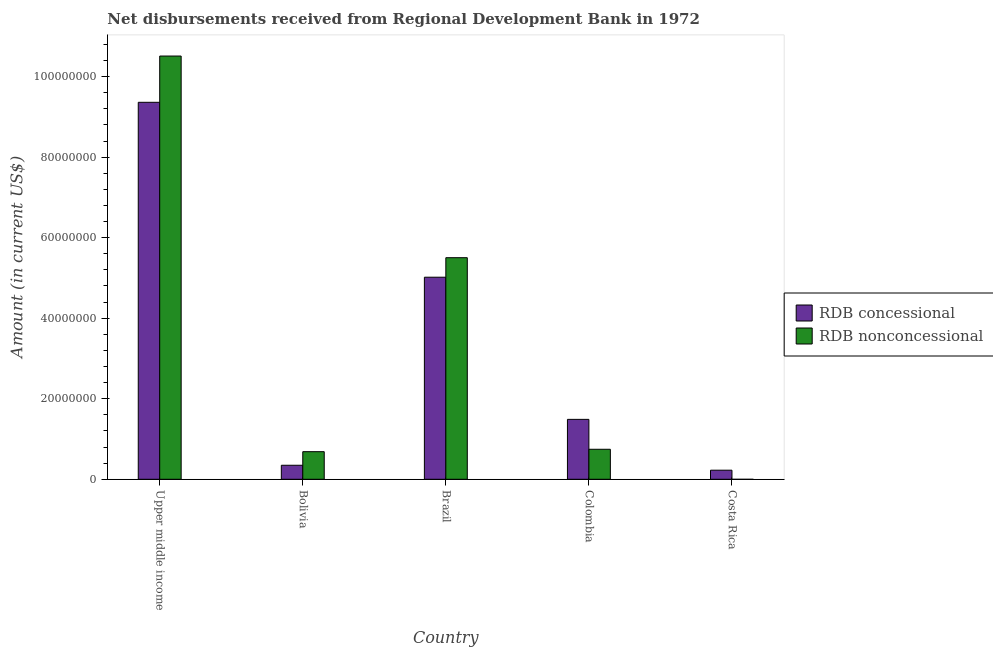Are the number of bars on each tick of the X-axis equal?
Your answer should be very brief. No. What is the net concessional disbursements from rdb in Brazil?
Offer a very short reply. 5.02e+07. Across all countries, what is the maximum net non concessional disbursements from rdb?
Ensure brevity in your answer.  1.05e+08. Across all countries, what is the minimum net concessional disbursements from rdb?
Keep it short and to the point. 2.26e+06. In which country was the net non concessional disbursements from rdb maximum?
Ensure brevity in your answer.  Upper middle income. What is the total net concessional disbursements from rdb in the graph?
Ensure brevity in your answer.  1.64e+08. What is the difference between the net concessional disbursements from rdb in Brazil and that in Upper middle income?
Keep it short and to the point. -4.34e+07. What is the difference between the net concessional disbursements from rdb in Brazil and the net non concessional disbursements from rdb in Colombia?
Your response must be concise. 4.27e+07. What is the average net non concessional disbursements from rdb per country?
Provide a short and direct response. 3.49e+07. What is the difference between the net concessional disbursements from rdb and net non concessional disbursements from rdb in Colombia?
Ensure brevity in your answer.  7.43e+06. In how many countries, is the net concessional disbursements from rdb greater than 64000000 US$?
Offer a very short reply. 1. What is the ratio of the net non concessional disbursements from rdb in Colombia to that in Upper middle income?
Provide a succinct answer. 0.07. Is the difference between the net concessional disbursements from rdb in Colombia and Upper middle income greater than the difference between the net non concessional disbursements from rdb in Colombia and Upper middle income?
Make the answer very short. Yes. What is the difference between the highest and the second highest net non concessional disbursements from rdb?
Provide a short and direct response. 5.01e+07. What is the difference between the highest and the lowest net concessional disbursements from rdb?
Ensure brevity in your answer.  9.14e+07. How many bars are there?
Your answer should be very brief. 9. Are all the bars in the graph horizontal?
Offer a terse response. No. How many countries are there in the graph?
Offer a terse response. 5. Are the values on the major ticks of Y-axis written in scientific E-notation?
Give a very brief answer. No. Does the graph contain any zero values?
Your response must be concise. Yes. How are the legend labels stacked?
Keep it short and to the point. Vertical. What is the title of the graph?
Your answer should be compact. Net disbursements received from Regional Development Bank in 1972. What is the label or title of the X-axis?
Keep it short and to the point. Country. What is the label or title of the Y-axis?
Give a very brief answer. Amount (in current US$). What is the Amount (in current US$) in RDB concessional in Upper middle income?
Give a very brief answer. 9.36e+07. What is the Amount (in current US$) of RDB nonconcessional in Upper middle income?
Offer a terse response. 1.05e+08. What is the Amount (in current US$) of RDB concessional in Bolivia?
Provide a short and direct response. 3.48e+06. What is the Amount (in current US$) in RDB nonconcessional in Bolivia?
Offer a very short reply. 6.85e+06. What is the Amount (in current US$) in RDB concessional in Brazil?
Offer a terse response. 5.02e+07. What is the Amount (in current US$) in RDB nonconcessional in Brazil?
Provide a succinct answer. 5.50e+07. What is the Amount (in current US$) in RDB concessional in Colombia?
Provide a succinct answer. 1.49e+07. What is the Amount (in current US$) in RDB nonconcessional in Colombia?
Offer a very short reply. 7.45e+06. What is the Amount (in current US$) in RDB concessional in Costa Rica?
Provide a short and direct response. 2.26e+06. What is the Amount (in current US$) in RDB nonconcessional in Costa Rica?
Your answer should be compact. 0. Across all countries, what is the maximum Amount (in current US$) in RDB concessional?
Ensure brevity in your answer.  9.36e+07. Across all countries, what is the maximum Amount (in current US$) in RDB nonconcessional?
Provide a succinct answer. 1.05e+08. Across all countries, what is the minimum Amount (in current US$) of RDB concessional?
Offer a very short reply. 2.26e+06. Across all countries, what is the minimum Amount (in current US$) of RDB nonconcessional?
Keep it short and to the point. 0. What is the total Amount (in current US$) of RDB concessional in the graph?
Provide a short and direct response. 1.64e+08. What is the total Amount (in current US$) of RDB nonconcessional in the graph?
Your response must be concise. 1.74e+08. What is the difference between the Amount (in current US$) of RDB concessional in Upper middle income and that in Bolivia?
Provide a short and direct response. 9.01e+07. What is the difference between the Amount (in current US$) in RDB nonconcessional in Upper middle income and that in Bolivia?
Ensure brevity in your answer.  9.82e+07. What is the difference between the Amount (in current US$) in RDB concessional in Upper middle income and that in Brazil?
Your response must be concise. 4.34e+07. What is the difference between the Amount (in current US$) of RDB nonconcessional in Upper middle income and that in Brazil?
Give a very brief answer. 5.01e+07. What is the difference between the Amount (in current US$) in RDB concessional in Upper middle income and that in Colombia?
Offer a terse response. 7.87e+07. What is the difference between the Amount (in current US$) in RDB nonconcessional in Upper middle income and that in Colombia?
Your answer should be compact. 9.76e+07. What is the difference between the Amount (in current US$) of RDB concessional in Upper middle income and that in Costa Rica?
Offer a terse response. 9.14e+07. What is the difference between the Amount (in current US$) of RDB concessional in Bolivia and that in Brazil?
Offer a very short reply. -4.67e+07. What is the difference between the Amount (in current US$) of RDB nonconcessional in Bolivia and that in Brazil?
Provide a short and direct response. -4.82e+07. What is the difference between the Amount (in current US$) of RDB concessional in Bolivia and that in Colombia?
Offer a terse response. -1.14e+07. What is the difference between the Amount (in current US$) of RDB nonconcessional in Bolivia and that in Colombia?
Your answer should be very brief. -5.97e+05. What is the difference between the Amount (in current US$) in RDB concessional in Bolivia and that in Costa Rica?
Make the answer very short. 1.22e+06. What is the difference between the Amount (in current US$) of RDB concessional in Brazil and that in Colombia?
Provide a succinct answer. 3.53e+07. What is the difference between the Amount (in current US$) of RDB nonconcessional in Brazil and that in Colombia?
Your response must be concise. 4.76e+07. What is the difference between the Amount (in current US$) of RDB concessional in Brazil and that in Costa Rica?
Offer a terse response. 4.79e+07. What is the difference between the Amount (in current US$) in RDB concessional in Colombia and that in Costa Rica?
Provide a succinct answer. 1.26e+07. What is the difference between the Amount (in current US$) of RDB concessional in Upper middle income and the Amount (in current US$) of RDB nonconcessional in Bolivia?
Offer a very short reply. 8.68e+07. What is the difference between the Amount (in current US$) of RDB concessional in Upper middle income and the Amount (in current US$) of RDB nonconcessional in Brazil?
Your answer should be compact. 3.86e+07. What is the difference between the Amount (in current US$) of RDB concessional in Upper middle income and the Amount (in current US$) of RDB nonconcessional in Colombia?
Offer a very short reply. 8.62e+07. What is the difference between the Amount (in current US$) in RDB concessional in Bolivia and the Amount (in current US$) in RDB nonconcessional in Brazil?
Give a very brief answer. -5.15e+07. What is the difference between the Amount (in current US$) in RDB concessional in Bolivia and the Amount (in current US$) in RDB nonconcessional in Colombia?
Ensure brevity in your answer.  -3.97e+06. What is the difference between the Amount (in current US$) of RDB concessional in Brazil and the Amount (in current US$) of RDB nonconcessional in Colombia?
Keep it short and to the point. 4.27e+07. What is the average Amount (in current US$) in RDB concessional per country?
Give a very brief answer. 3.29e+07. What is the average Amount (in current US$) of RDB nonconcessional per country?
Provide a short and direct response. 3.49e+07. What is the difference between the Amount (in current US$) in RDB concessional and Amount (in current US$) in RDB nonconcessional in Upper middle income?
Provide a short and direct response. -1.15e+07. What is the difference between the Amount (in current US$) in RDB concessional and Amount (in current US$) in RDB nonconcessional in Bolivia?
Offer a terse response. -3.37e+06. What is the difference between the Amount (in current US$) in RDB concessional and Amount (in current US$) in RDB nonconcessional in Brazil?
Your answer should be compact. -4.84e+06. What is the difference between the Amount (in current US$) of RDB concessional and Amount (in current US$) of RDB nonconcessional in Colombia?
Your response must be concise. 7.43e+06. What is the ratio of the Amount (in current US$) of RDB concessional in Upper middle income to that in Bolivia?
Provide a succinct answer. 26.9. What is the ratio of the Amount (in current US$) in RDB nonconcessional in Upper middle income to that in Bolivia?
Your response must be concise. 15.34. What is the ratio of the Amount (in current US$) in RDB concessional in Upper middle income to that in Brazil?
Your response must be concise. 1.87. What is the ratio of the Amount (in current US$) of RDB nonconcessional in Upper middle income to that in Brazil?
Give a very brief answer. 1.91. What is the ratio of the Amount (in current US$) in RDB concessional in Upper middle income to that in Colombia?
Your response must be concise. 6.29. What is the ratio of the Amount (in current US$) of RDB nonconcessional in Upper middle income to that in Colombia?
Your answer should be very brief. 14.11. What is the ratio of the Amount (in current US$) in RDB concessional in Upper middle income to that in Costa Rica?
Give a very brief answer. 41.49. What is the ratio of the Amount (in current US$) in RDB concessional in Bolivia to that in Brazil?
Offer a very short reply. 0.07. What is the ratio of the Amount (in current US$) of RDB nonconcessional in Bolivia to that in Brazil?
Make the answer very short. 0.12. What is the ratio of the Amount (in current US$) in RDB concessional in Bolivia to that in Colombia?
Your answer should be compact. 0.23. What is the ratio of the Amount (in current US$) in RDB nonconcessional in Bolivia to that in Colombia?
Ensure brevity in your answer.  0.92. What is the ratio of the Amount (in current US$) of RDB concessional in Bolivia to that in Costa Rica?
Your answer should be very brief. 1.54. What is the ratio of the Amount (in current US$) of RDB concessional in Brazil to that in Colombia?
Offer a terse response. 3.37. What is the ratio of the Amount (in current US$) in RDB nonconcessional in Brazil to that in Colombia?
Keep it short and to the point. 7.39. What is the ratio of the Amount (in current US$) of RDB concessional in Brazil to that in Costa Rica?
Give a very brief answer. 22.24. What is the ratio of the Amount (in current US$) in RDB concessional in Colombia to that in Costa Rica?
Your answer should be compact. 6.59. What is the difference between the highest and the second highest Amount (in current US$) of RDB concessional?
Your answer should be very brief. 4.34e+07. What is the difference between the highest and the second highest Amount (in current US$) in RDB nonconcessional?
Offer a terse response. 5.01e+07. What is the difference between the highest and the lowest Amount (in current US$) of RDB concessional?
Offer a terse response. 9.14e+07. What is the difference between the highest and the lowest Amount (in current US$) in RDB nonconcessional?
Offer a very short reply. 1.05e+08. 